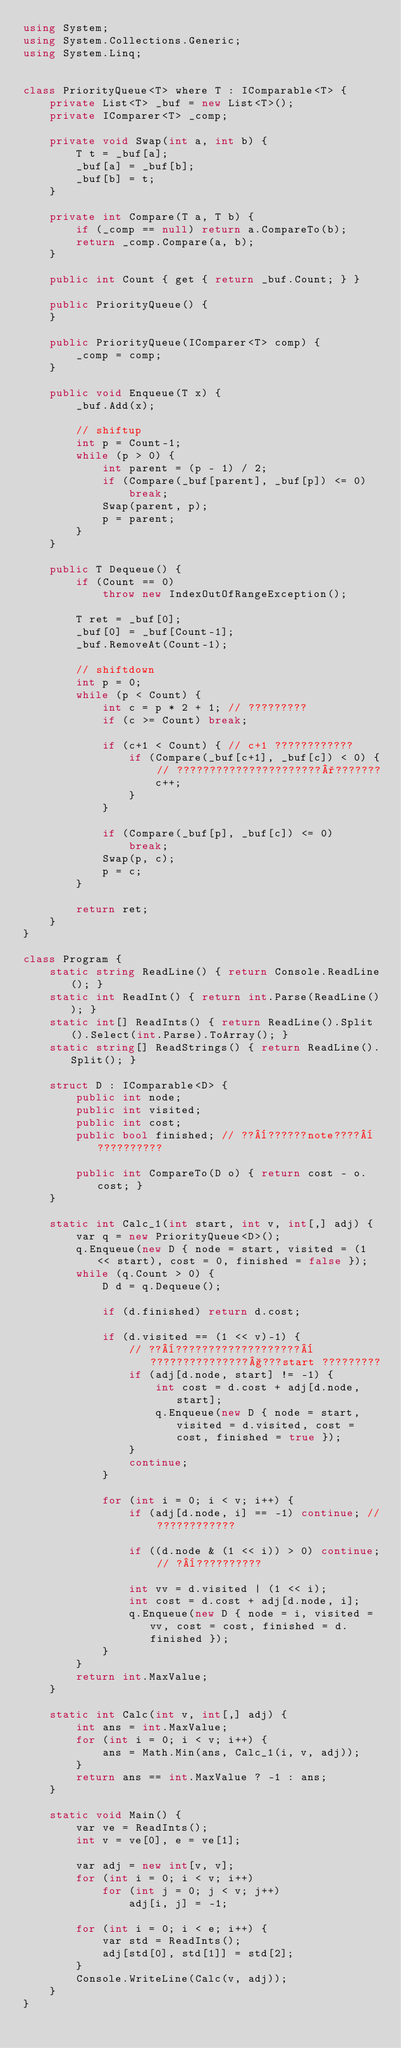Convert code to text. <code><loc_0><loc_0><loc_500><loc_500><_C#_>using System;
using System.Collections.Generic;
using System.Linq;


class PriorityQueue<T> where T : IComparable<T> {
    private List<T> _buf = new List<T>();
    private IComparer<T> _comp;

    private void Swap(int a, int b) {
        T t = _buf[a];
        _buf[a] = _buf[b];
        _buf[b] = t;
    }

    private int Compare(T a, T b) {
        if (_comp == null) return a.CompareTo(b);
        return _comp.Compare(a, b);
    }

    public int Count { get { return _buf.Count; } }

    public PriorityQueue() {
    }

    public PriorityQueue(IComparer<T> comp) {
        _comp = comp;
    }

    public void Enqueue(T x) {
        _buf.Add(x);

        // shiftup
        int p = Count-1;
        while (p > 0) {
            int parent = (p - 1) / 2;
            if (Compare(_buf[parent], _buf[p]) <= 0)
                break;
            Swap(parent, p);
            p = parent;
        }
    }

    public T Dequeue() {
        if (Count == 0)
            throw new IndexOutOfRangeException();

        T ret = _buf[0];
        _buf[0] = _buf[Count-1];
        _buf.RemoveAt(Count-1);

        // shiftdown
        int p = 0;
        while (p < Count) {
            int c = p * 2 + 1; // ?????????
            if (c >= Count) break;

            if (c+1 < Count) { // c+1 ????????????
                if (Compare(_buf[c+1], _buf[c]) < 0) { // ??????????????????????°???????
                    c++;
                }
            }

            if (Compare(_buf[p], _buf[c]) <= 0)
                break;
            Swap(p, c);
            p = c;
        }

        return ret;
    }
}

class Program {
    static string ReadLine() { return Console.ReadLine(); }
    static int ReadInt() { return int.Parse(ReadLine()); }
    static int[] ReadInts() { return ReadLine().Split().Select(int.Parse).ToArray(); }
    static string[] ReadStrings() { return ReadLine().Split(); }

    struct D : IComparable<D> {
        public int node;
        public int visited;
        public int cost;
        public bool finished; // ??¨??????note????¨??????????

        public int CompareTo(D o) { return cost - o.cost; }
    }

    static int Calc_1(int start, int v, int[,] adj) {
        var q = new PriorityQueue<D>();
        q.Enqueue(new D { node = start, visited = (1 << start), cost = 0, finished = false });
        while (q.Count > 0) {
            D d = q.Dequeue();

            if (d.finished) return d.cost;

            if (d.visited == (1 << v)-1) {
                // ??¨???????????????????¨???????????????§???start ?????????
                if (adj[d.node, start] != -1) {
                    int cost = d.cost + adj[d.node, start];
                    q.Enqueue(new D { node = start, visited = d.visited, cost = cost, finished = true });
                }
                continue;
            }

            for (int i = 0; i < v; i++) {
                if (adj[d.node, i] == -1) continue; // ????????????

                if ((d.node & (1 << i)) > 0) continue; // ?¨??????????

                int vv = d.visited | (1 << i);
                int cost = d.cost + adj[d.node, i];
                q.Enqueue(new D { node = i, visited = vv, cost = cost, finished = d.finished });
            }
        }
        return int.MaxValue;
    }

    static int Calc(int v, int[,] adj) {
        int ans = int.MaxValue;
        for (int i = 0; i < v; i++) {
            ans = Math.Min(ans, Calc_1(i, v, adj));
        }
        return ans == int.MaxValue ? -1 : ans;
    }

    static void Main() {
        var ve = ReadInts();
        int v = ve[0], e = ve[1];

        var adj = new int[v, v];
        for (int i = 0; i < v; i++)
            for (int j = 0; j < v; j++)
                adj[i, j] = -1;

        for (int i = 0; i < e; i++) {
            var std = ReadInts();
            adj[std[0], std[1]] = std[2];
        }
        Console.WriteLine(Calc(v, adj));
    }
}</code> 